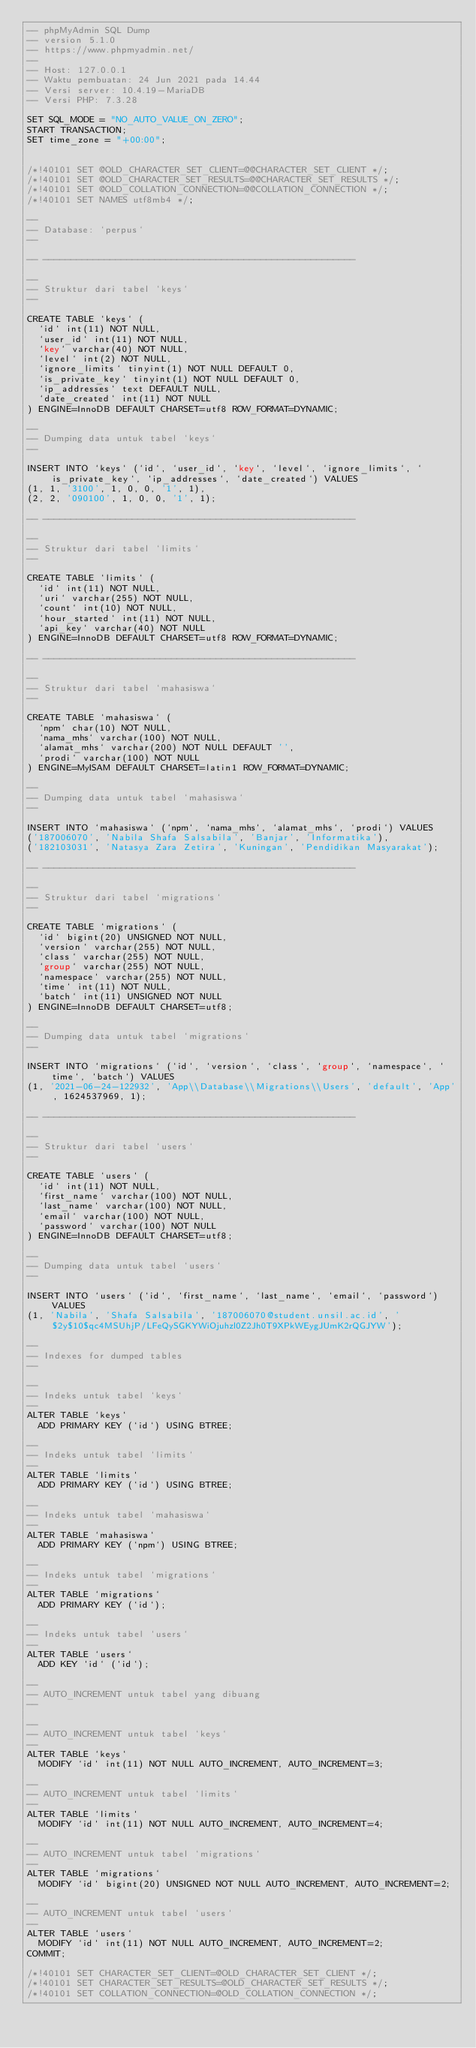Convert code to text. <code><loc_0><loc_0><loc_500><loc_500><_SQL_>-- phpMyAdmin SQL Dump
-- version 5.1.0
-- https://www.phpmyadmin.net/
--
-- Host: 127.0.0.1
-- Waktu pembuatan: 24 Jun 2021 pada 14.44
-- Versi server: 10.4.19-MariaDB
-- Versi PHP: 7.3.28

SET SQL_MODE = "NO_AUTO_VALUE_ON_ZERO";
START TRANSACTION;
SET time_zone = "+00:00";


/*!40101 SET @OLD_CHARACTER_SET_CLIENT=@@CHARACTER_SET_CLIENT */;
/*!40101 SET @OLD_CHARACTER_SET_RESULTS=@@CHARACTER_SET_RESULTS */;
/*!40101 SET @OLD_COLLATION_CONNECTION=@@COLLATION_CONNECTION */;
/*!40101 SET NAMES utf8mb4 */;

--
-- Database: `perpus`
--

-- --------------------------------------------------------

--
-- Struktur dari tabel `keys`
--

CREATE TABLE `keys` (
  `id` int(11) NOT NULL,
  `user_id` int(11) NOT NULL,
  `key` varchar(40) NOT NULL,
  `level` int(2) NOT NULL,
  `ignore_limits` tinyint(1) NOT NULL DEFAULT 0,
  `is_private_key` tinyint(1) NOT NULL DEFAULT 0,
  `ip_addresses` text DEFAULT NULL,
  `date_created` int(11) NOT NULL
) ENGINE=InnoDB DEFAULT CHARSET=utf8 ROW_FORMAT=DYNAMIC;

--
-- Dumping data untuk tabel `keys`
--

INSERT INTO `keys` (`id`, `user_id`, `key`, `level`, `ignore_limits`, `is_private_key`, `ip_addresses`, `date_created`) VALUES
(1, 1, '3100', 1, 0, 0, '1', 1),
(2, 2, '090100', 1, 0, 0, '1', 1);

-- --------------------------------------------------------

--
-- Struktur dari tabel `limits`
--

CREATE TABLE `limits` (
  `id` int(11) NOT NULL,
  `uri` varchar(255) NOT NULL,
  `count` int(10) NOT NULL,
  `hour_started` int(11) NOT NULL,
  `api_key` varchar(40) NOT NULL
) ENGINE=InnoDB DEFAULT CHARSET=utf8 ROW_FORMAT=DYNAMIC;

-- --------------------------------------------------------

--
-- Struktur dari tabel `mahasiswa`
--

CREATE TABLE `mahasiswa` (
  `npm` char(10) NOT NULL,
  `nama_mhs` varchar(100) NOT NULL,
  `alamat_mhs` varchar(200) NOT NULL DEFAULT '',
  `prodi` varchar(100) NOT NULL
) ENGINE=MyISAM DEFAULT CHARSET=latin1 ROW_FORMAT=DYNAMIC;

--
-- Dumping data untuk tabel `mahasiswa`
--

INSERT INTO `mahasiswa` (`npm`, `nama_mhs`, `alamat_mhs`, `prodi`) VALUES
('187006070', 'Nabila Shafa Salsabila', 'Banjar', 'Informatika'),
('182103031', 'Natasya Zara Zetira', 'Kuningan', 'Pendidikan Masyarakat');

-- --------------------------------------------------------

--
-- Struktur dari tabel `migrations`
--

CREATE TABLE `migrations` (
  `id` bigint(20) UNSIGNED NOT NULL,
  `version` varchar(255) NOT NULL,
  `class` varchar(255) NOT NULL,
  `group` varchar(255) NOT NULL,
  `namespace` varchar(255) NOT NULL,
  `time` int(11) NOT NULL,
  `batch` int(11) UNSIGNED NOT NULL
) ENGINE=InnoDB DEFAULT CHARSET=utf8;

--
-- Dumping data untuk tabel `migrations`
--

INSERT INTO `migrations` (`id`, `version`, `class`, `group`, `namespace`, `time`, `batch`) VALUES
(1, '2021-06-24-122932', 'App\\Database\\Migrations\\Users', 'default', 'App', 1624537969, 1);

-- --------------------------------------------------------

--
-- Struktur dari tabel `users`
--

CREATE TABLE `users` (
  `id` int(11) NOT NULL,
  `first_name` varchar(100) NOT NULL,
  `last_name` varchar(100) NOT NULL,
  `email` varchar(100) NOT NULL,
  `password` varchar(100) NOT NULL
) ENGINE=InnoDB DEFAULT CHARSET=utf8;

--
-- Dumping data untuk tabel `users`
--

INSERT INTO `users` (`id`, `first_name`, `last_name`, `email`, `password`) VALUES
(1, 'Nabila', 'Shafa Salsabila', '187006070@student.unsil.ac.id', '$2y$10$qc4MSUhjP/LFeQySGKYWiOjuhzl0Z2Jh0T9XPkWEygJUmK2rQGJYW');

--
-- Indexes for dumped tables
--

--
-- Indeks untuk tabel `keys`
--
ALTER TABLE `keys`
  ADD PRIMARY KEY (`id`) USING BTREE;

--
-- Indeks untuk tabel `limits`
--
ALTER TABLE `limits`
  ADD PRIMARY KEY (`id`) USING BTREE;

--
-- Indeks untuk tabel `mahasiswa`
--
ALTER TABLE `mahasiswa`
  ADD PRIMARY KEY (`npm`) USING BTREE;

--
-- Indeks untuk tabel `migrations`
--
ALTER TABLE `migrations`
  ADD PRIMARY KEY (`id`);

--
-- Indeks untuk tabel `users`
--
ALTER TABLE `users`
  ADD KEY `id` (`id`);

--
-- AUTO_INCREMENT untuk tabel yang dibuang
--

--
-- AUTO_INCREMENT untuk tabel `keys`
--
ALTER TABLE `keys`
  MODIFY `id` int(11) NOT NULL AUTO_INCREMENT, AUTO_INCREMENT=3;

--
-- AUTO_INCREMENT untuk tabel `limits`
--
ALTER TABLE `limits`
  MODIFY `id` int(11) NOT NULL AUTO_INCREMENT, AUTO_INCREMENT=4;

--
-- AUTO_INCREMENT untuk tabel `migrations`
--
ALTER TABLE `migrations`
  MODIFY `id` bigint(20) UNSIGNED NOT NULL AUTO_INCREMENT, AUTO_INCREMENT=2;

--
-- AUTO_INCREMENT untuk tabel `users`
--
ALTER TABLE `users`
  MODIFY `id` int(11) NOT NULL AUTO_INCREMENT, AUTO_INCREMENT=2;
COMMIT;

/*!40101 SET CHARACTER_SET_CLIENT=@OLD_CHARACTER_SET_CLIENT */;
/*!40101 SET CHARACTER_SET_RESULTS=@OLD_CHARACTER_SET_RESULTS */;
/*!40101 SET COLLATION_CONNECTION=@OLD_COLLATION_CONNECTION */;
</code> 